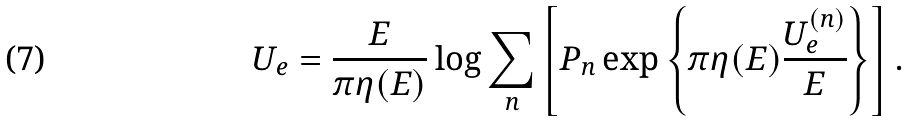<formula> <loc_0><loc_0><loc_500><loc_500>U _ { e } = \frac { E } { \pi \eta ( E ) } \log \sum _ { n } \left [ P _ { n } \exp \left \{ \pi \eta ( E ) \frac { U _ { e } ^ { ( n ) } } { E } \right \} \right ] .</formula> 